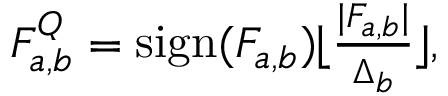Convert formula to latex. <formula><loc_0><loc_0><loc_500><loc_500>\begin{array} { r } { F _ { a , b } ^ { Q } = s i g n ( F _ { a , b } ) \lfloor \frac { | F _ { a , b } | } { \Delta _ { b } } \rfloor , } \end{array}</formula> 